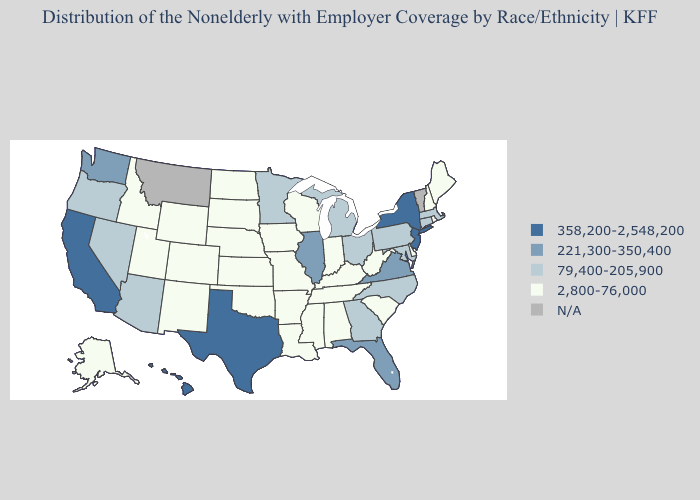What is the highest value in states that border Indiana?
Give a very brief answer. 221,300-350,400. Name the states that have a value in the range 221,300-350,400?
Quick response, please. Florida, Illinois, Virginia, Washington. What is the value of Illinois?
Answer briefly. 221,300-350,400. What is the highest value in the West ?
Short answer required. 358,200-2,548,200. What is the highest value in the MidWest ?
Quick response, please. 221,300-350,400. Among the states that border Nebraska , which have the lowest value?
Give a very brief answer. Colorado, Iowa, Kansas, Missouri, South Dakota, Wyoming. Among the states that border Michigan , does Indiana have the highest value?
Give a very brief answer. No. Among the states that border Nebraska , which have the lowest value?
Quick response, please. Colorado, Iowa, Kansas, Missouri, South Dakota, Wyoming. What is the value of Louisiana?
Short answer required. 2,800-76,000. Which states hav the highest value in the West?
Answer briefly. California, Hawaii. Name the states that have a value in the range N/A?
Give a very brief answer. Montana, Vermont. What is the highest value in the Northeast ?
Concise answer only. 358,200-2,548,200. Does North Carolina have the highest value in the USA?
Be succinct. No. Is the legend a continuous bar?
Short answer required. No. 